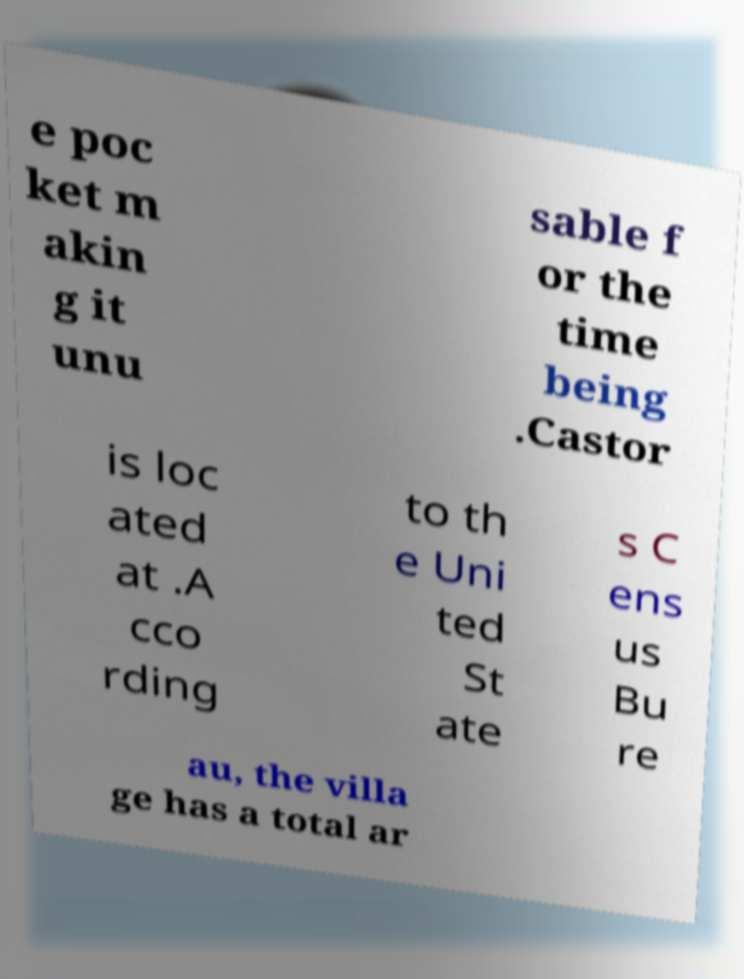What messages or text are displayed in this image? I need them in a readable, typed format. e poc ket m akin g it unu sable f or the time being .Castor is loc ated at .A cco rding to th e Uni ted St ate s C ens us Bu re au, the villa ge has a total ar 